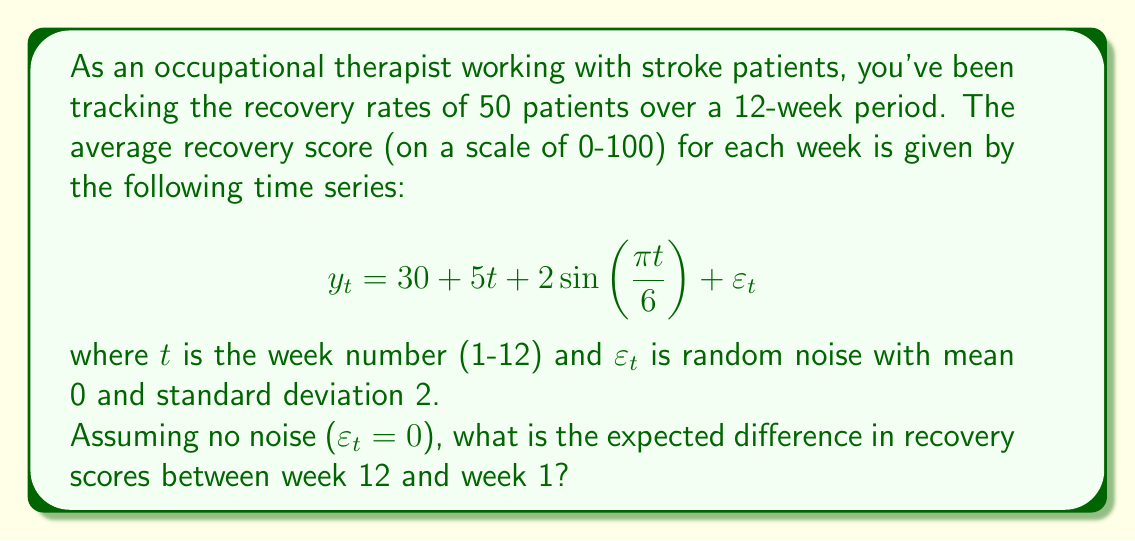Can you answer this question? To solve this problem, we need to calculate the expected recovery scores for week 1 and week 12, then find the difference. Let's break it down step-by-step:

1. For week 1 ($t = 1$):
   $$y_1 = 30 + 5(1) + 2\sin(\frac{\pi(1)}{6})$$
   $$y_1 = 35 + 2\sin(\frac{\pi}{6})$$
   $$y_1 = 35 + 2(0.5) = 36$$

2. For week 12 ($t = 12$):
   $$y_{12} = 30 + 5(12) + 2\sin(\frac{\pi(12)}{6})$$
   $$y_{12} = 90 + 2\sin(2\pi)$$
   $$y_{12} = 90 + 2(0) = 90$$

3. Calculate the difference:
   $$\text{Difference} = y_{12} - y_1 = 90 - 36 = 54$$

The expected difference in recovery scores between week 12 and week 1 is 54 points.

Note: The sinusoidal term $2\sin(\frac{\pi t}{6})$ represents a cyclical component with a period of 12 weeks. It reaches its maximum at $t = 3$ and $t = 9$, and its minimum at $t = 6$ and $t = 12$. This could represent fluctuations in recovery rates due to factors such as patient motivation or therapy intensity.
Answer: 54 points 